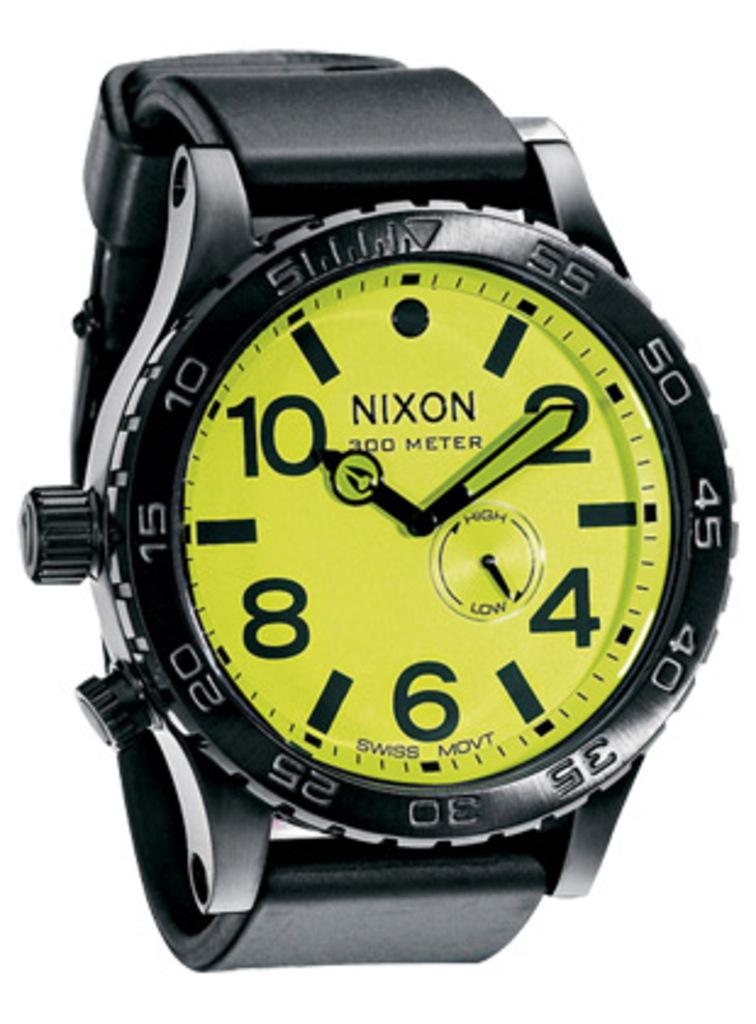<image>
Provide a brief description of the given image. The Nixon watch probably glows in the dark. 